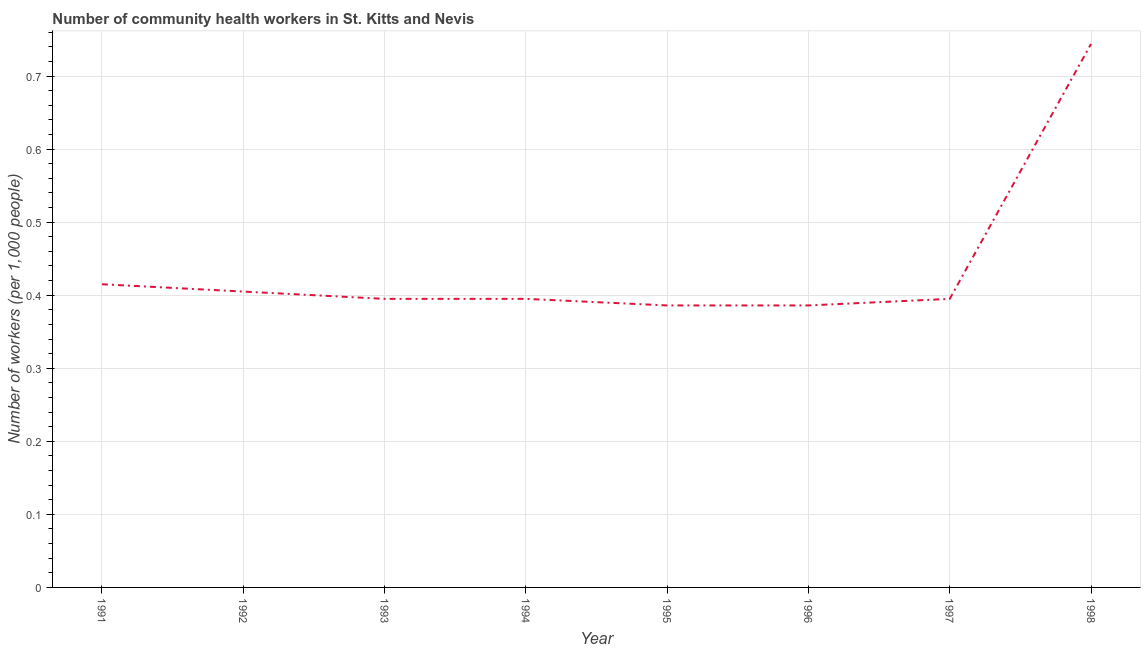What is the number of community health workers in 1996?
Make the answer very short. 0.39. Across all years, what is the maximum number of community health workers?
Offer a terse response. 0.74. Across all years, what is the minimum number of community health workers?
Your answer should be very brief. 0.39. In which year was the number of community health workers maximum?
Provide a short and direct response. 1998. In which year was the number of community health workers minimum?
Provide a succinct answer. 1995. What is the sum of the number of community health workers?
Ensure brevity in your answer.  3.52. What is the difference between the number of community health workers in 1991 and 1998?
Your answer should be compact. -0.33. What is the average number of community health workers per year?
Give a very brief answer. 0.44. What is the median number of community health workers?
Give a very brief answer. 0.4. What is the ratio of the number of community health workers in 1991 to that in 1996?
Provide a succinct answer. 1.08. Is the number of community health workers in 1992 less than that in 1998?
Offer a very short reply. Yes. Is the difference between the number of community health workers in 1994 and 1996 greater than the difference between any two years?
Your answer should be compact. No. What is the difference between the highest and the second highest number of community health workers?
Give a very brief answer. 0.33. What is the difference between the highest and the lowest number of community health workers?
Make the answer very short. 0.36. Does the number of community health workers monotonically increase over the years?
Offer a terse response. No. How many years are there in the graph?
Keep it short and to the point. 8. What is the difference between two consecutive major ticks on the Y-axis?
Provide a short and direct response. 0.1. Are the values on the major ticks of Y-axis written in scientific E-notation?
Your answer should be very brief. No. Does the graph contain any zero values?
Provide a succinct answer. No. What is the title of the graph?
Keep it short and to the point. Number of community health workers in St. Kitts and Nevis. What is the label or title of the X-axis?
Provide a short and direct response. Year. What is the label or title of the Y-axis?
Ensure brevity in your answer.  Number of workers (per 1,0 people). What is the Number of workers (per 1,000 people) of 1991?
Offer a terse response. 0.41. What is the Number of workers (per 1,000 people) in 1992?
Make the answer very short. 0.41. What is the Number of workers (per 1,000 people) in 1993?
Give a very brief answer. 0.4. What is the Number of workers (per 1,000 people) of 1994?
Your response must be concise. 0.4. What is the Number of workers (per 1,000 people) of 1995?
Keep it short and to the point. 0.39. What is the Number of workers (per 1,000 people) of 1996?
Make the answer very short. 0.39. What is the Number of workers (per 1,000 people) of 1997?
Offer a terse response. 0.4. What is the Number of workers (per 1,000 people) of 1998?
Offer a very short reply. 0.74. What is the difference between the Number of workers (per 1,000 people) in 1991 and 1993?
Ensure brevity in your answer.  0.02. What is the difference between the Number of workers (per 1,000 people) in 1991 and 1995?
Your answer should be compact. 0.03. What is the difference between the Number of workers (per 1,000 people) in 1991 and 1996?
Provide a short and direct response. 0.03. What is the difference between the Number of workers (per 1,000 people) in 1991 and 1997?
Provide a succinct answer. 0.02. What is the difference between the Number of workers (per 1,000 people) in 1991 and 1998?
Give a very brief answer. -0.33. What is the difference between the Number of workers (per 1,000 people) in 1992 and 1993?
Your answer should be very brief. 0.01. What is the difference between the Number of workers (per 1,000 people) in 1992 and 1994?
Ensure brevity in your answer.  0.01. What is the difference between the Number of workers (per 1,000 people) in 1992 and 1995?
Your response must be concise. 0.02. What is the difference between the Number of workers (per 1,000 people) in 1992 and 1996?
Offer a very short reply. 0.02. What is the difference between the Number of workers (per 1,000 people) in 1992 and 1997?
Your response must be concise. 0.01. What is the difference between the Number of workers (per 1,000 people) in 1992 and 1998?
Provide a short and direct response. -0.34. What is the difference between the Number of workers (per 1,000 people) in 1993 and 1994?
Your answer should be very brief. 0. What is the difference between the Number of workers (per 1,000 people) in 1993 and 1995?
Ensure brevity in your answer.  0.01. What is the difference between the Number of workers (per 1,000 people) in 1993 and 1996?
Offer a very short reply. 0.01. What is the difference between the Number of workers (per 1,000 people) in 1993 and 1997?
Your response must be concise. 0. What is the difference between the Number of workers (per 1,000 people) in 1993 and 1998?
Make the answer very short. -0.35. What is the difference between the Number of workers (per 1,000 people) in 1994 and 1995?
Keep it short and to the point. 0.01. What is the difference between the Number of workers (per 1,000 people) in 1994 and 1996?
Ensure brevity in your answer.  0.01. What is the difference between the Number of workers (per 1,000 people) in 1994 and 1998?
Keep it short and to the point. -0.35. What is the difference between the Number of workers (per 1,000 people) in 1995 and 1997?
Offer a terse response. -0.01. What is the difference between the Number of workers (per 1,000 people) in 1995 and 1998?
Provide a short and direct response. -0.36. What is the difference between the Number of workers (per 1,000 people) in 1996 and 1997?
Give a very brief answer. -0.01. What is the difference between the Number of workers (per 1,000 people) in 1996 and 1998?
Give a very brief answer. -0.36. What is the difference between the Number of workers (per 1,000 people) in 1997 and 1998?
Give a very brief answer. -0.35. What is the ratio of the Number of workers (per 1,000 people) in 1991 to that in 1992?
Ensure brevity in your answer.  1.02. What is the ratio of the Number of workers (per 1,000 people) in 1991 to that in 1993?
Your response must be concise. 1.05. What is the ratio of the Number of workers (per 1,000 people) in 1991 to that in 1994?
Give a very brief answer. 1.05. What is the ratio of the Number of workers (per 1,000 people) in 1991 to that in 1995?
Make the answer very short. 1.07. What is the ratio of the Number of workers (per 1,000 people) in 1991 to that in 1996?
Your answer should be very brief. 1.07. What is the ratio of the Number of workers (per 1,000 people) in 1991 to that in 1997?
Give a very brief answer. 1.05. What is the ratio of the Number of workers (per 1,000 people) in 1991 to that in 1998?
Provide a succinct answer. 0.56. What is the ratio of the Number of workers (per 1,000 people) in 1992 to that in 1994?
Your response must be concise. 1.02. What is the ratio of the Number of workers (per 1,000 people) in 1992 to that in 1995?
Your answer should be compact. 1.05. What is the ratio of the Number of workers (per 1,000 people) in 1992 to that in 1996?
Ensure brevity in your answer.  1.05. What is the ratio of the Number of workers (per 1,000 people) in 1992 to that in 1998?
Provide a short and direct response. 0.54. What is the ratio of the Number of workers (per 1,000 people) in 1993 to that in 1994?
Your answer should be compact. 1. What is the ratio of the Number of workers (per 1,000 people) in 1993 to that in 1996?
Keep it short and to the point. 1.02. What is the ratio of the Number of workers (per 1,000 people) in 1993 to that in 1998?
Provide a succinct answer. 0.53. What is the ratio of the Number of workers (per 1,000 people) in 1994 to that in 1996?
Give a very brief answer. 1.02. What is the ratio of the Number of workers (per 1,000 people) in 1994 to that in 1997?
Offer a very short reply. 1. What is the ratio of the Number of workers (per 1,000 people) in 1994 to that in 1998?
Make the answer very short. 0.53. What is the ratio of the Number of workers (per 1,000 people) in 1995 to that in 1998?
Provide a succinct answer. 0.52. What is the ratio of the Number of workers (per 1,000 people) in 1996 to that in 1998?
Offer a terse response. 0.52. What is the ratio of the Number of workers (per 1,000 people) in 1997 to that in 1998?
Ensure brevity in your answer.  0.53. 